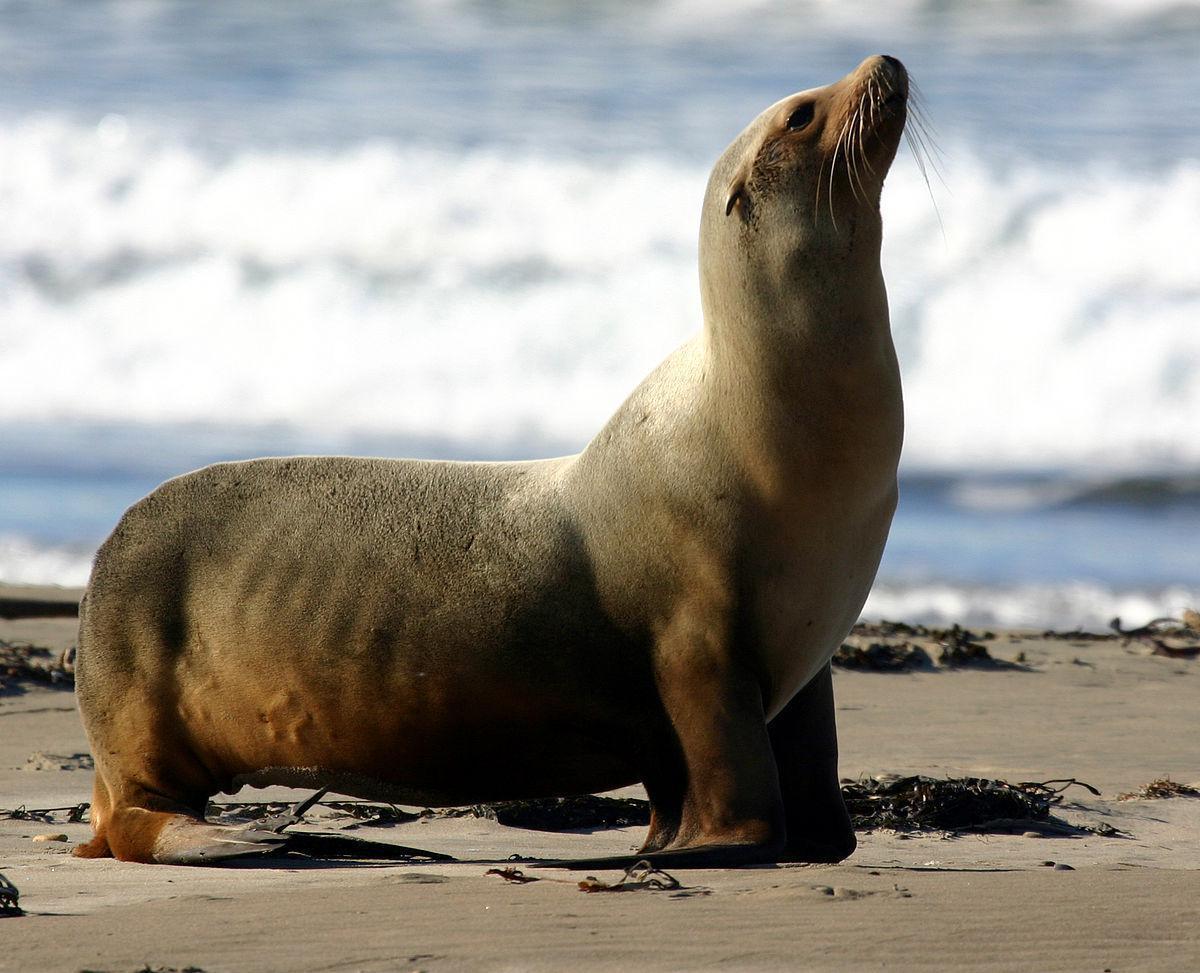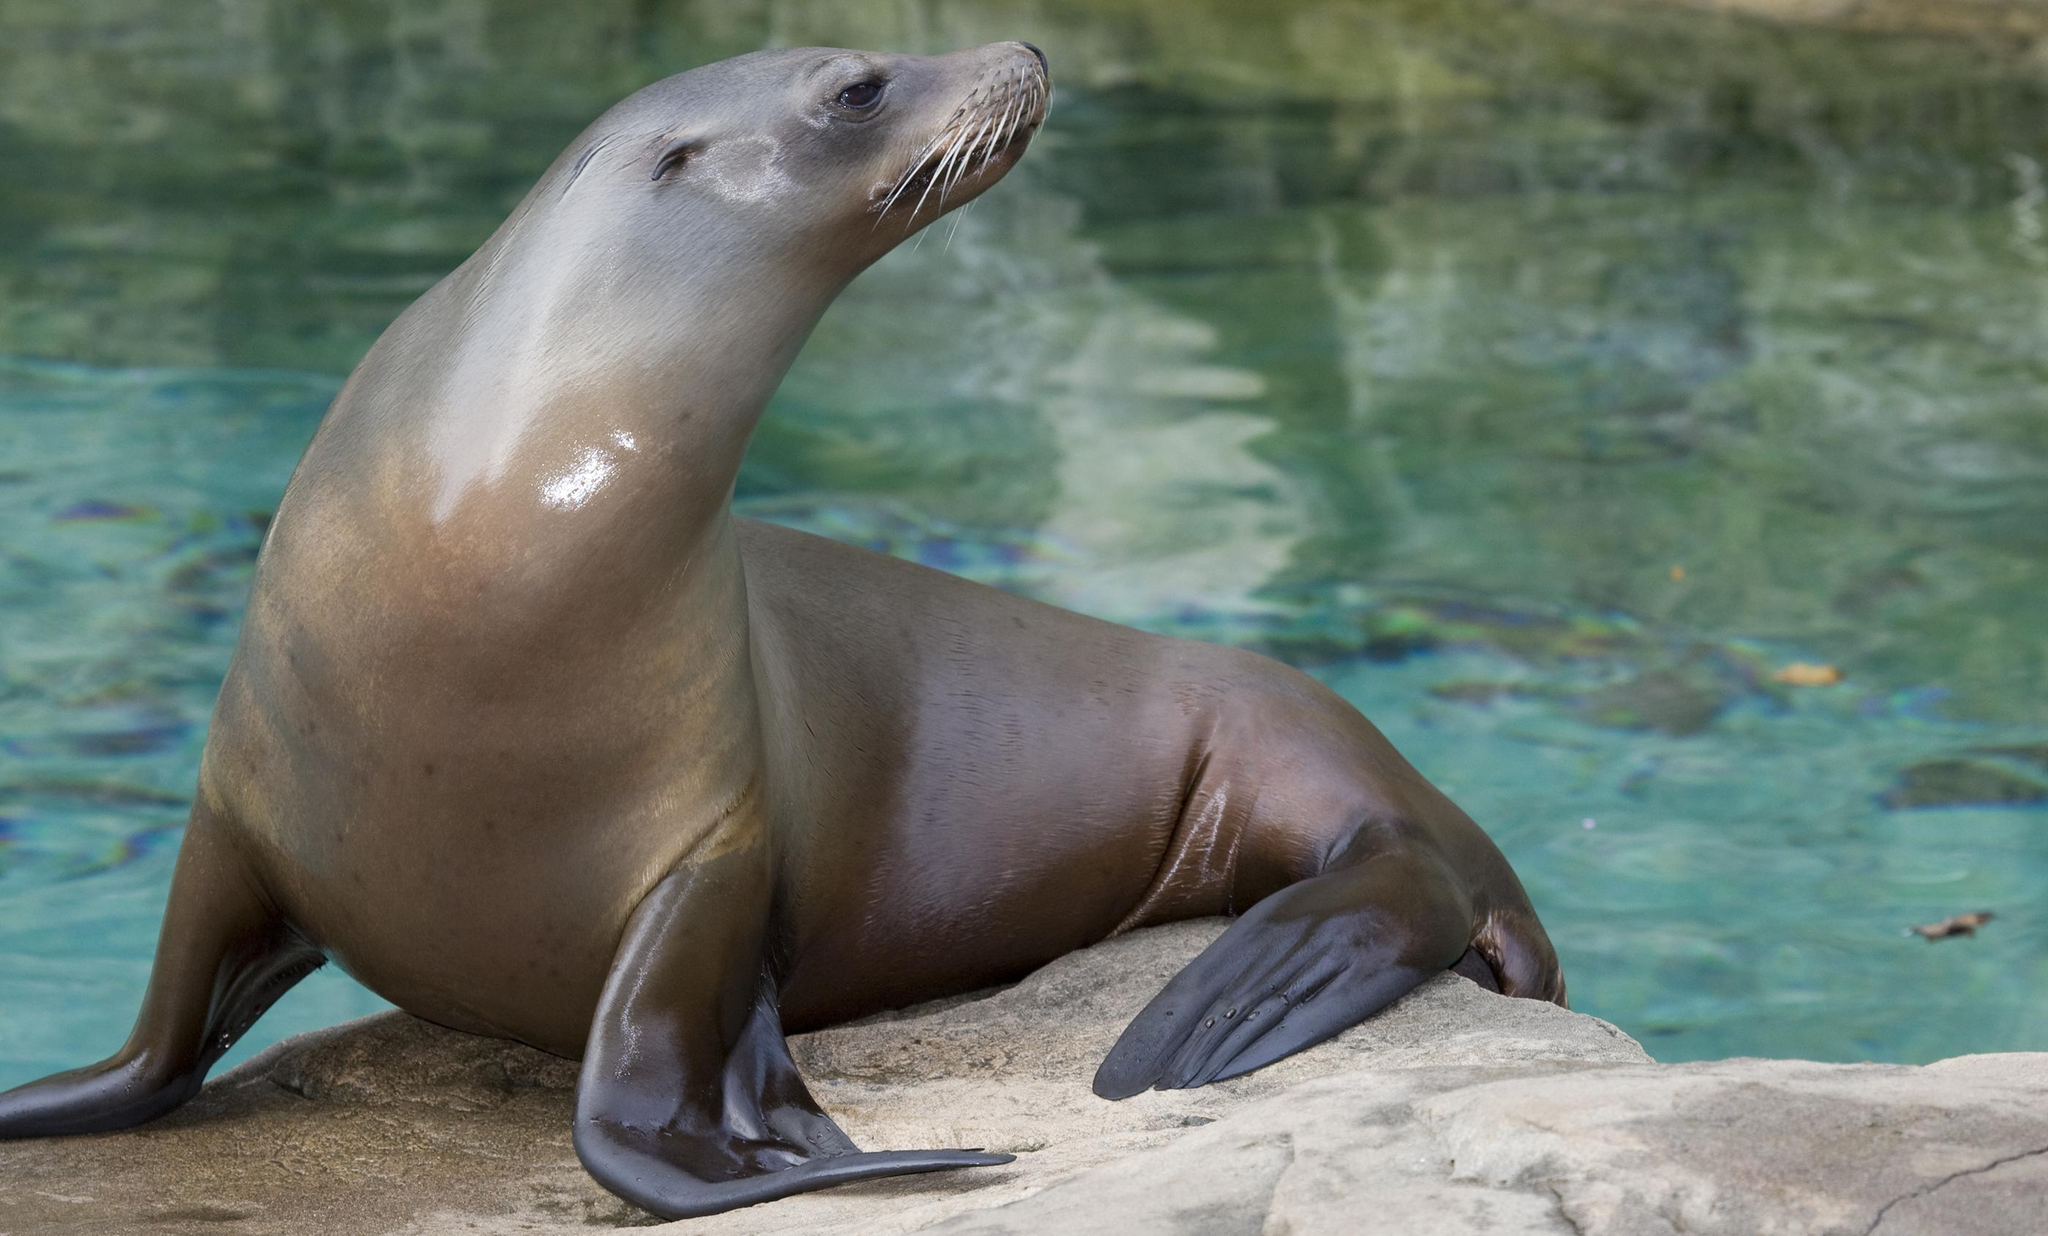The first image is the image on the left, the second image is the image on the right. Assess this claim about the two images: "The right image includes a sleek gray seal with raised right-turned head and body turned to the camera, perched on a large rock in front of blue-green water.". Correct or not? Answer yes or no. Yes. The first image is the image on the left, the second image is the image on the right. Considering the images on both sides, is "The right image contains two seals." valid? Answer yes or no. No. 